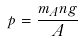Convert formula to latex. <formula><loc_0><loc_0><loc_500><loc_500>p = \frac { m _ { A } n g } { A }</formula> 